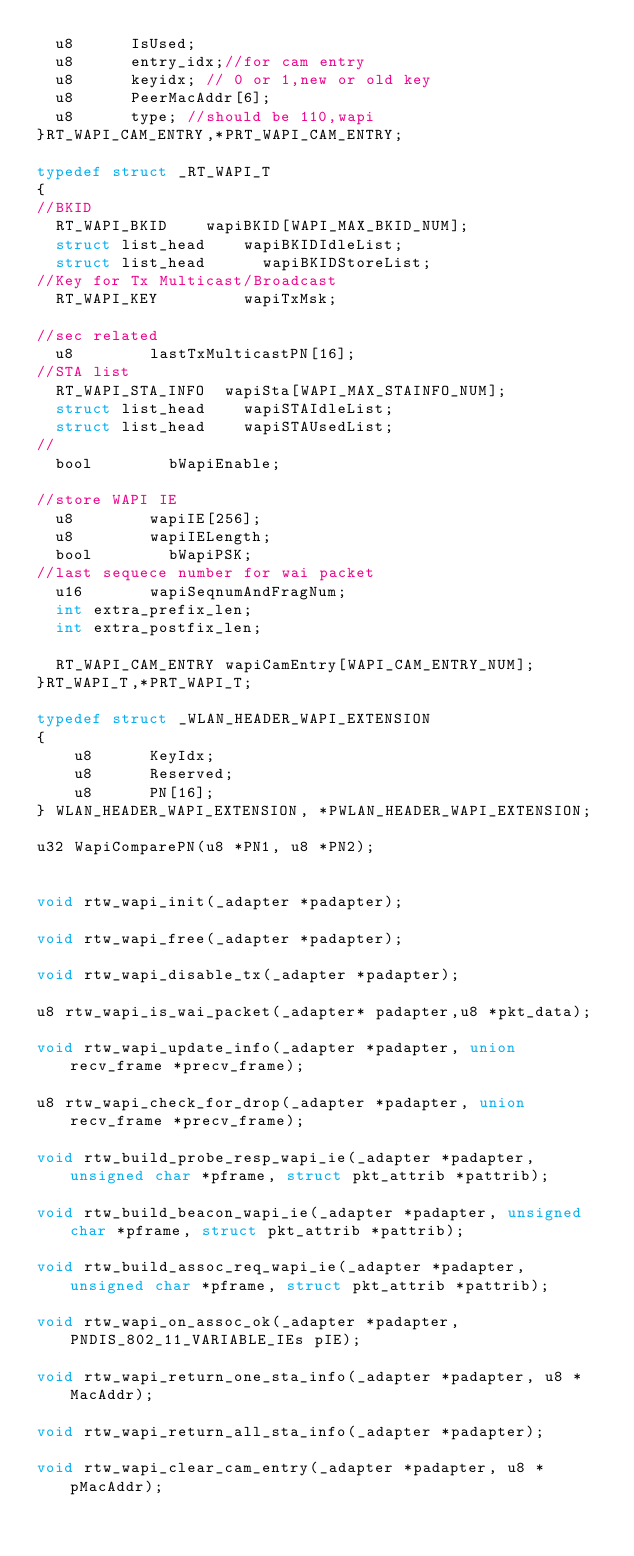Convert code to text. <code><loc_0><loc_0><loc_500><loc_500><_C_>	u8			IsUsed;
	u8			entry_idx;//for cam entry
	u8			keyidx;	// 0 or 1,new or old key
	u8			PeerMacAddr[6];
	u8			type;	//should be 110,wapi
}RT_WAPI_CAM_ENTRY,*PRT_WAPI_CAM_ENTRY;

typedef struct _RT_WAPI_T
{
//BKID
	RT_WAPI_BKID		wapiBKID[WAPI_MAX_BKID_NUM];
	struct list_head		wapiBKIDIdleList;
	struct list_head  		wapiBKIDStoreList;
//Key for Tx Multicast/Broadcast
	RT_WAPI_KEY		      wapiTxMsk;

//sec related
	u8				lastTxMulticastPN[16];
//STA list
	RT_WAPI_STA_INFO	wapiSta[WAPI_MAX_STAINFO_NUM];
	struct list_head		wapiSTAIdleList;
	struct list_head		wapiSTAUsedList;
//
	bool				bWapiEnable;

//store WAPI IE
	u8				wapiIE[256];
	u8				wapiIELength;
	bool				bWapiPSK;
//last sequece number for wai packet
	u16				wapiSeqnumAndFragNum;
	int extra_prefix_len;
	int extra_postfix_len;

	RT_WAPI_CAM_ENTRY	wapiCamEntry[WAPI_CAM_ENTRY_NUM];
}RT_WAPI_T,*PRT_WAPI_T;

typedef struct _WLAN_HEADER_WAPI_EXTENSION
{
    u8      KeyIdx;
    u8      Reserved;
    u8      PN[16];
} WLAN_HEADER_WAPI_EXTENSION, *PWLAN_HEADER_WAPI_EXTENSION;

u32 WapiComparePN(u8 *PN1, u8 *PN2);


void rtw_wapi_init(_adapter *padapter);

void rtw_wapi_free(_adapter *padapter);

void rtw_wapi_disable_tx(_adapter *padapter);

u8 rtw_wapi_is_wai_packet(_adapter* padapter,u8 *pkt_data);

void rtw_wapi_update_info(_adapter *padapter, union recv_frame *precv_frame);

u8 rtw_wapi_check_for_drop(_adapter *padapter, union recv_frame *precv_frame);

void rtw_build_probe_resp_wapi_ie(_adapter *padapter, unsigned char *pframe, struct pkt_attrib *pattrib);

void rtw_build_beacon_wapi_ie(_adapter *padapter, unsigned char *pframe, struct pkt_attrib *pattrib);

void rtw_build_assoc_req_wapi_ie(_adapter *padapter, unsigned char *pframe, struct pkt_attrib *pattrib);

void rtw_wapi_on_assoc_ok(_adapter *padapter, PNDIS_802_11_VARIABLE_IEs pIE);

void rtw_wapi_return_one_sta_info(_adapter *padapter, u8 *MacAddr);

void rtw_wapi_return_all_sta_info(_adapter *padapter);

void rtw_wapi_clear_cam_entry(_adapter *padapter, u8 *pMacAddr);
</code> 